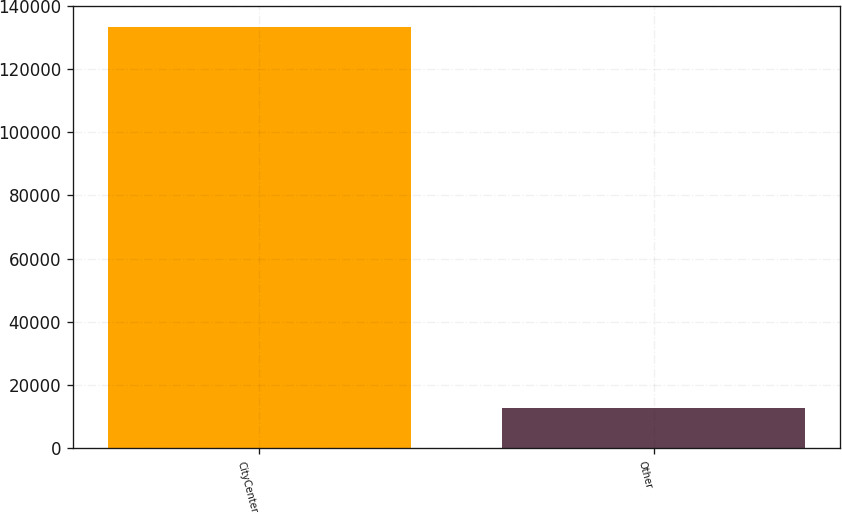Convert chart. <chart><loc_0><loc_0><loc_500><loc_500><bar_chart><fcel>CityCenter<fcel>Other<nl><fcel>133400<fcel>12822<nl></chart> 